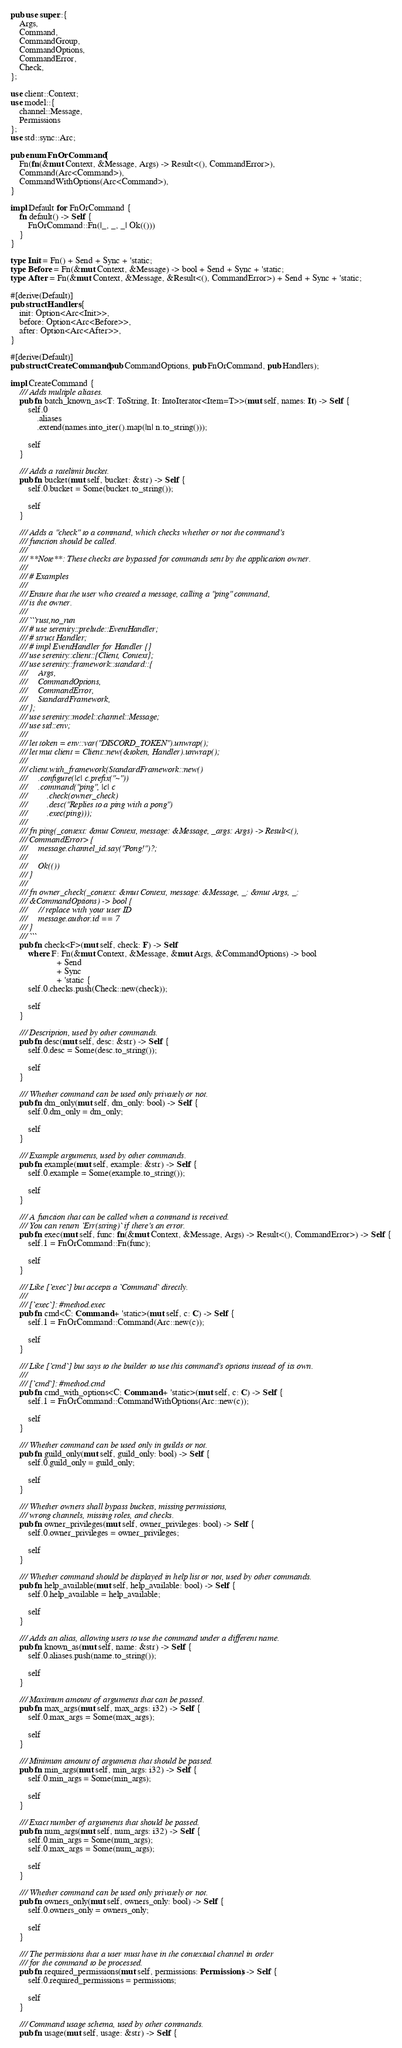<code> <loc_0><loc_0><loc_500><loc_500><_Rust_>pub use super::{
    Args,
    Command,
    CommandGroup,
    CommandOptions,
    CommandError,
    Check,
};

use client::Context;
use model::{
    channel::Message,
    Permissions
};
use std::sync::Arc;

pub enum FnOrCommand {
    Fn(fn(&mut Context, &Message, Args) -> Result<(), CommandError>),
    Command(Arc<Command>),
    CommandWithOptions(Arc<Command>),
}

impl Default for FnOrCommand {
    fn default() -> Self {
        FnOrCommand::Fn(|_, _, _| Ok(()))
    }
}

type Init = Fn() + Send + Sync + 'static;
type Before = Fn(&mut Context, &Message) -> bool + Send + Sync + 'static;
type After = Fn(&mut Context, &Message, &Result<(), CommandError>) + Send + Sync + 'static;

#[derive(Default)]
pub struct Handlers {
    init: Option<Arc<Init>>,
    before: Option<Arc<Before>>,
    after: Option<Arc<After>>,
}

#[derive(Default)]
pub struct CreateCommand(pub CommandOptions, pub FnOrCommand, pub Handlers);

impl CreateCommand {
    /// Adds multiple aliases.
    pub fn batch_known_as<T: ToString, It: IntoIterator<Item=T>>(mut self, names: It) -> Self {
        self.0
            .aliases
            .extend(names.into_iter().map(|n| n.to_string()));

        self
    }

    /// Adds a ratelimit bucket.
    pub fn bucket(mut self, bucket: &str) -> Self {
        self.0.bucket = Some(bucket.to_string());

        self
    }

    /// Adds a "check" to a command, which checks whether or not the command's
    /// function should be called.
    ///
    /// **Note**: These checks are bypassed for commands sent by the application owner.
    ///
    /// # Examples
    ///
    /// Ensure that the user who created a message, calling a "ping" command,
    /// is the owner.
    ///
    /// ```rust,no_run
    /// # use serenity::prelude::EventHandler;
    /// # struct Handler;
    /// # impl EventHandler for Handler {}
    /// use serenity::client::{Client, Context};
    /// use serenity::framework::standard::{
    ///     Args,
    ///     CommandOptions,
    ///     CommandError,
    ///     StandardFramework,
    /// };
    /// use serenity::model::channel::Message;
    /// use std::env;
    ///
    /// let token = env::var("DISCORD_TOKEN").unwrap();
    /// let mut client = Client::new(&token, Handler).unwrap();
    ///
    /// client.with_framework(StandardFramework::new()
    ///     .configure(|c| c.prefix("~"))
    ///     .command("ping", |c| c
    ///         .check(owner_check)
    ///         .desc("Replies to a ping with a pong")
    ///         .exec(ping)));
    ///
    /// fn ping(_context: &mut Context, message: &Message, _args: Args) -> Result<(),
    /// CommandError> {
    ///     message.channel_id.say("Pong!")?;
    ///
    ///     Ok(())
    /// }
    ///
    /// fn owner_check(_context: &mut Context, message: &Message, _: &mut Args, _:
    /// &CommandOptions) -> bool {
    ///     // replace with your user ID
    ///     message.author.id == 7
    /// }
    /// ```
    pub fn check<F>(mut self, check: F) -> Self
        where F: Fn(&mut Context, &Message, &mut Args, &CommandOptions) -> bool
                     + Send
                     + Sync
                     + 'static {
        self.0.checks.push(Check::new(check));

        self
    }

    /// Description, used by other commands.
    pub fn desc(mut self, desc: &str) -> Self {
        self.0.desc = Some(desc.to_string());

        self
    }

    /// Whether command can be used only privately or not.
    pub fn dm_only(mut self, dm_only: bool) -> Self {
        self.0.dm_only = dm_only;

        self
    }

    /// Example arguments, used by other commands.
    pub fn example(mut self, example: &str) -> Self {
        self.0.example = Some(example.to_string());

        self
    }

    /// A function that can be called when a command is received.
    /// You can return `Err(string)` if there's an error.
    pub fn exec(mut self, func: fn(&mut Context, &Message, Args) -> Result<(), CommandError>) -> Self {
        self.1 = FnOrCommand::Fn(func);

        self
    }

    /// Like [`exec`] but accepts a `Command` directly.
    ///
    /// [`exec`]: #method.exec
    pub fn cmd<C: Command + 'static>(mut self, c: C) -> Self {
        self.1 = FnOrCommand::Command(Arc::new(c));

        self
    }

    /// Like [`cmd`] but says to the builder to use this command's options instead of its own.
    ///
    /// [`cmd`]: #method.cmd
    pub fn cmd_with_options<C: Command + 'static>(mut self, c: C) -> Self {
        self.1 = FnOrCommand::CommandWithOptions(Arc::new(c));

        self
    }

    /// Whether command can be used only in guilds or not.
    pub fn guild_only(mut self, guild_only: bool) -> Self {
        self.0.guild_only = guild_only;

        self
    }

    /// Whether owners shall bypass buckets, missing permissions,
    /// wrong channels, missing roles, and checks.
    pub fn owner_privileges(mut self, owner_privileges: bool) -> Self {
        self.0.owner_privileges = owner_privileges;

        self
    }

    /// Whether command should be displayed in help list or not, used by other commands.
    pub fn help_available(mut self, help_available: bool) -> Self {
        self.0.help_available = help_available;

        self
    }

    /// Adds an alias, allowing users to use the command under a different name.
    pub fn known_as(mut self, name: &str) -> Self {
        self.0.aliases.push(name.to_string());

        self
    }

    /// Maximum amount of arguments that can be passed.
    pub fn max_args(mut self, max_args: i32) -> Self {
        self.0.max_args = Some(max_args);

        self
    }

    /// Minimum amount of arguments that should be passed.
    pub fn min_args(mut self, min_args: i32) -> Self {
        self.0.min_args = Some(min_args);

        self
    }

    /// Exact number of arguments that should be passed.
    pub fn num_args(mut self, num_args: i32) -> Self {
        self.0.min_args = Some(num_args);
        self.0.max_args = Some(num_args);

        self
    }

    /// Whether command can be used only privately or not.
    pub fn owners_only(mut self, owners_only: bool) -> Self {
        self.0.owners_only = owners_only;

        self
    }

    /// The permissions that a user must have in the contextual channel in order
    /// for the command to be processed.
    pub fn required_permissions(mut self, permissions: Permissions) -> Self {
        self.0.required_permissions = permissions;

        self
    }

    /// Command usage schema, used by other commands.
    pub fn usage(mut self, usage: &str) -> Self {</code> 